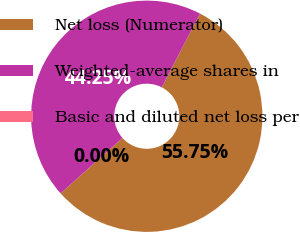<chart> <loc_0><loc_0><loc_500><loc_500><pie_chart><fcel>Net loss (Numerator)<fcel>Weighted-average shares in<fcel>Basic and diluted net loss per<nl><fcel>55.75%<fcel>44.25%<fcel>0.0%<nl></chart> 